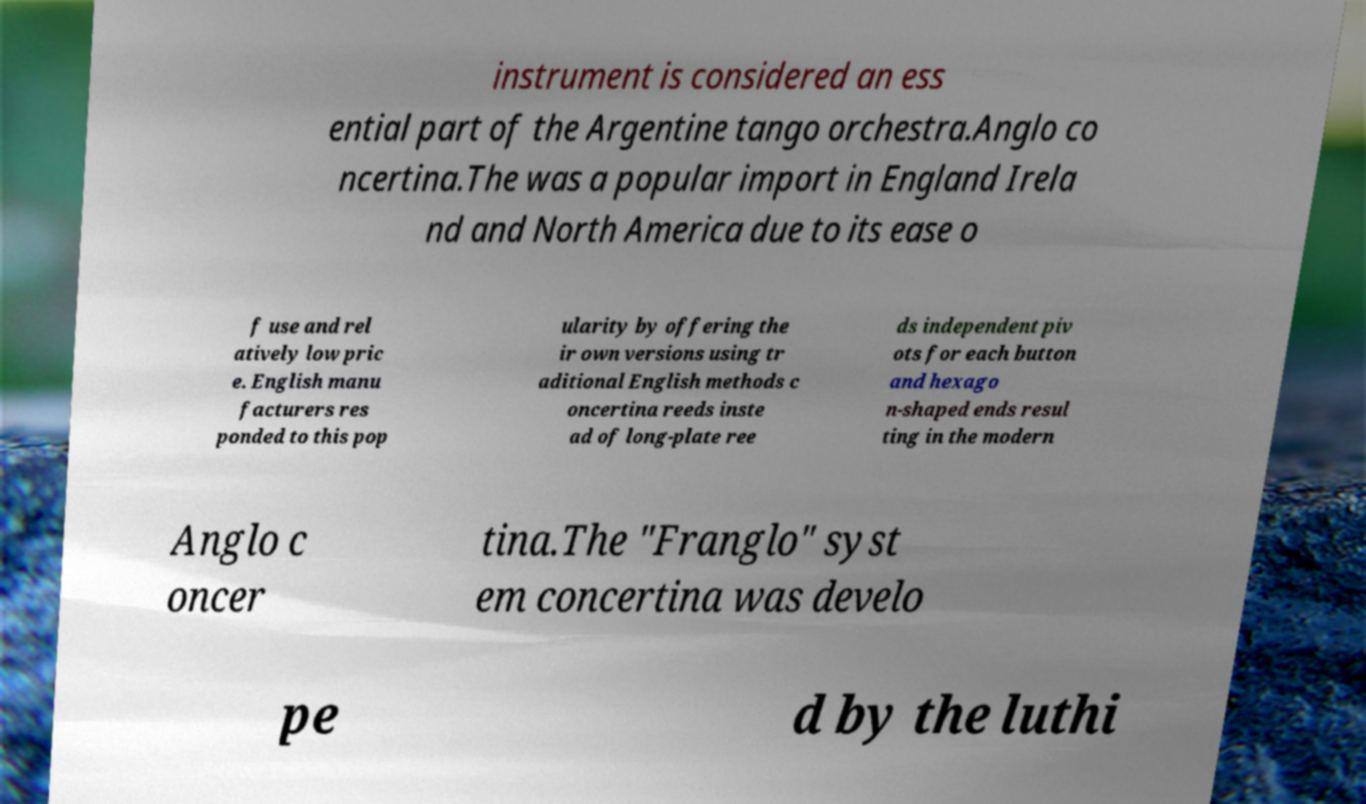Please read and relay the text visible in this image. What does it say? instrument is considered an ess ential part of the Argentine tango orchestra.Anglo co ncertina.The was a popular import in England Irela nd and North America due to its ease o f use and rel atively low pric e. English manu facturers res ponded to this pop ularity by offering the ir own versions using tr aditional English methods c oncertina reeds inste ad of long-plate ree ds independent piv ots for each button and hexago n-shaped ends resul ting in the modern Anglo c oncer tina.The "Franglo" syst em concertina was develo pe d by the luthi 